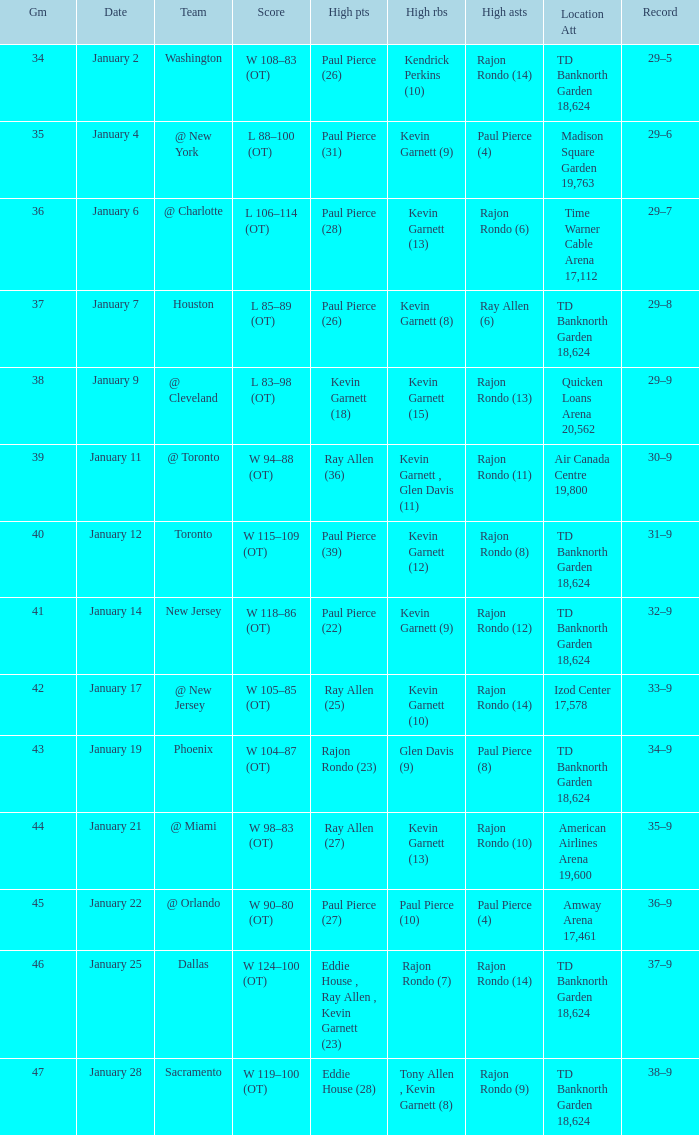Who had the high rebound total on january 6? Kevin Garnett (13). 